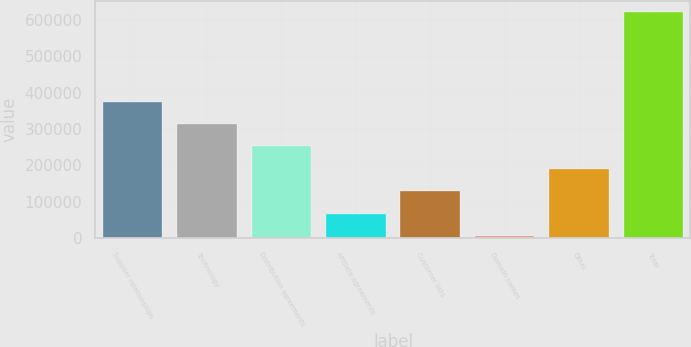<chart> <loc_0><loc_0><loc_500><loc_500><bar_chart><fcel>Supplier relationships<fcel>Technology<fcel>Distribution agreements<fcel>Affiliate agreements<fcel>Customer lists<fcel>Domain names<fcel>Other<fcel>Total<nl><fcel>375374<fcel>313766<fcel>252159<fcel>67336.5<fcel>128944<fcel>5729<fcel>190552<fcel>621804<nl></chart> 